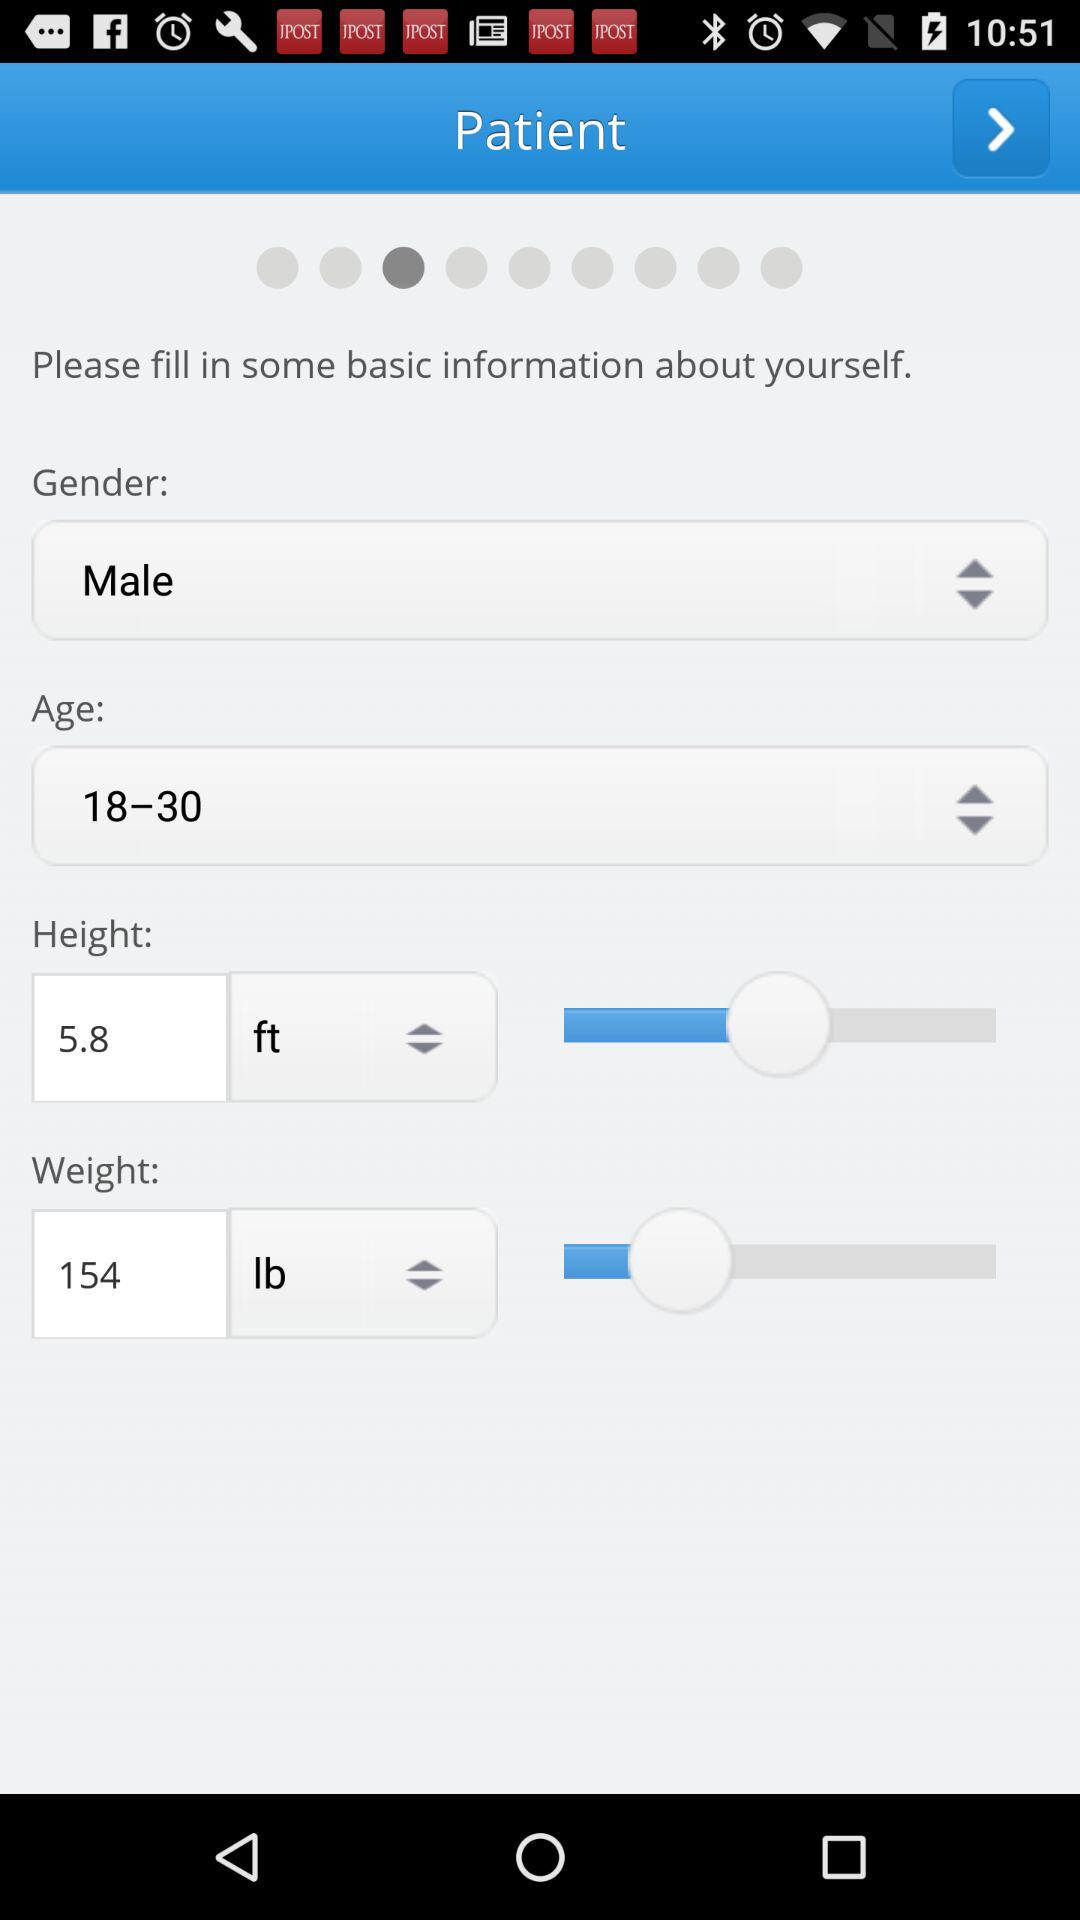What's the height? The height is 5.8 ft. 